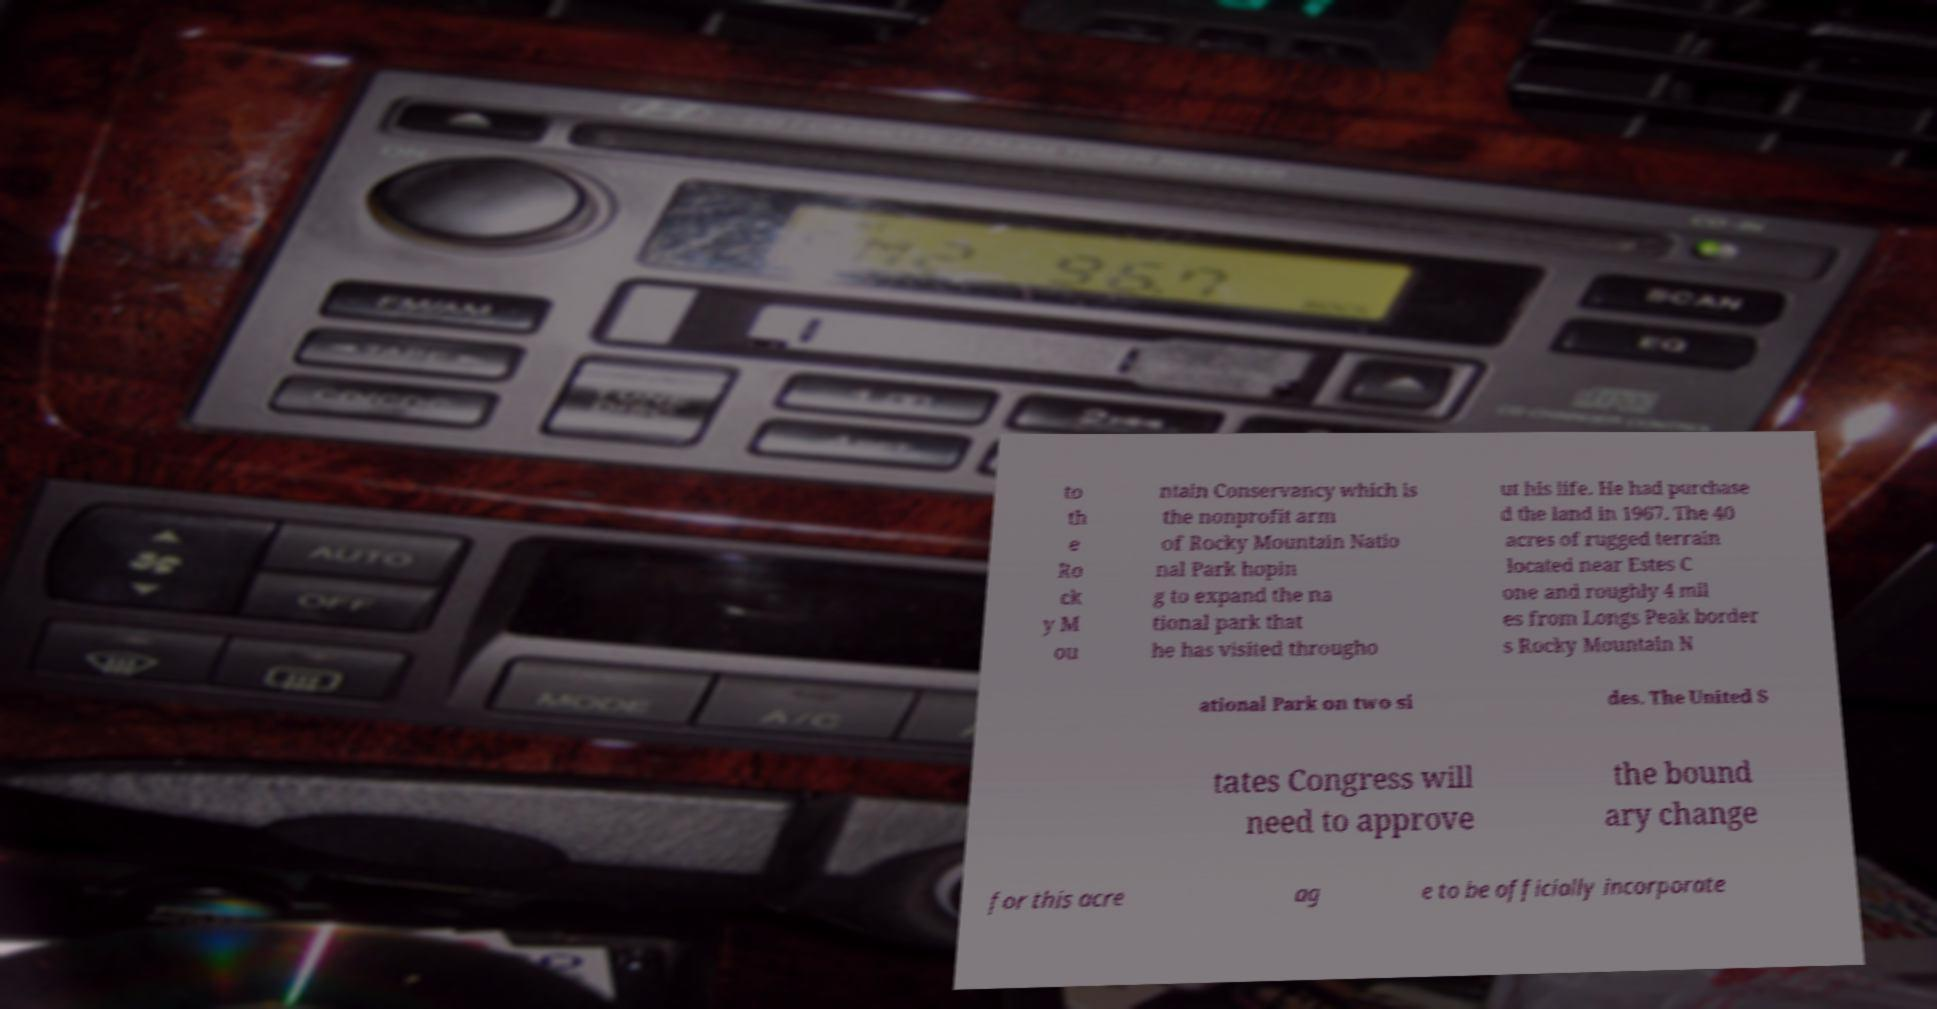There's text embedded in this image that I need extracted. Can you transcribe it verbatim? to th e Ro ck y M ou ntain Conservancy which is the nonprofit arm of Rocky Mountain Natio nal Park hopin g to expand the na tional park that he has visited througho ut his life. He had purchase d the land in 1967. The 40 acres of rugged terrain located near Estes C one and roughly 4 mil es from Longs Peak border s Rocky Mountain N ational Park on two si des. The United S tates Congress will need to approve the bound ary change for this acre ag e to be officially incorporate 